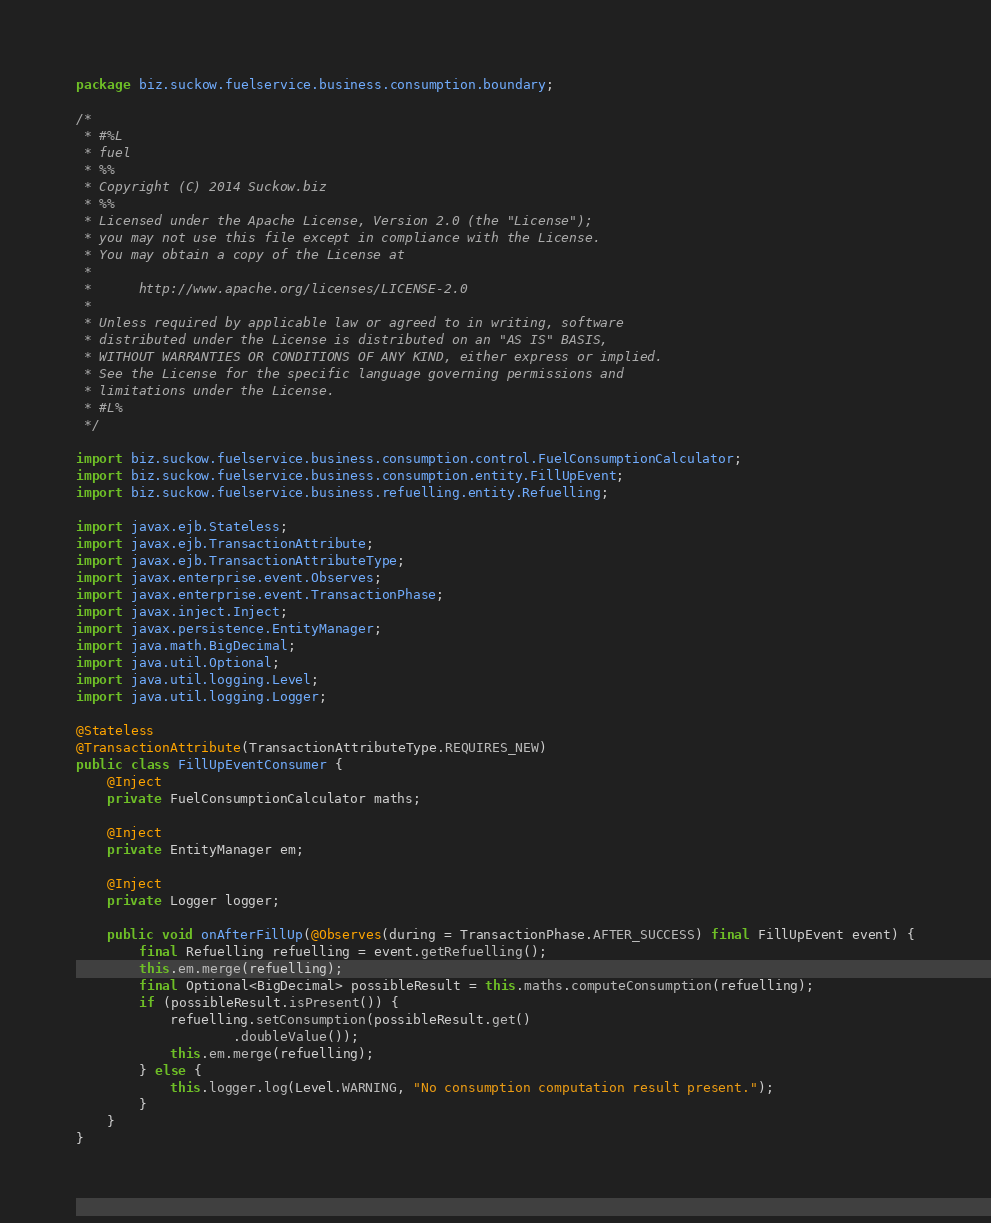<code> <loc_0><loc_0><loc_500><loc_500><_Java_>package biz.suckow.fuelservice.business.consumption.boundary;

/*
 * #%L
 * fuel
 * %%
 * Copyright (C) 2014 Suckow.biz
 * %%
 * Licensed under the Apache License, Version 2.0 (the "License");
 * you may not use this file except in compliance with the License.
 * You may obtain a copy of the License at
 * 
 *      http://www.apache.org/licenses/LICENSE-2.0
 * 
 * Unless required by applicable law or agreed to in writing, software
 * distributed under the License is distributed on an "AS IS" BASIS,
 * WITHOUT WARRANTIES OR CONDITIONS OF ANY KIND, either express or implied.
 * See the License for the specific language governing permissions and
 * limitations under the License.
 * #L%
 */

import biz.suckow.fuelservice.business.consumption.control.FuelConsumptionCalculator;
import biz.suckow.fuelservice.business.consumption.entity.FillUpEvent;
import biz.suckow.fuelservice.business.refuelling.entity.Refuelling;

import javax.ejb.Stateless;
import javax.ejb.TransactionAttribute;
import javax.ejb.TransactionAttributeType;
import javax.enterprise.event.Observes;
import javax.enterprise.event.TransactionPhase;
import javax.inject.Inject;
import javax.persistence.EntityManager;
import java.math.BigDecimal;
import java.util.Optional;
import java.util.logging.Level;
import java.util.logging.Logger;

@Stateless
@TransactionAttribute(TransactionAttributeType.REQUIRES_NEW)
public class FillUpEventConsumer {
    @Inject
    private FuelConsumptionCalculator maths;

    @Inject
    private EntityManager em;

    @Inject
    private Logger logger;

    public void onAfterFillUp(@Observes(during = TransactionPhase.AFTER_SUCCESS) final FillUpEvent event) {
        final Refuelling refuelling = event.getRefuelling();
        this.em.merge(refuelling);
        final Optional<BigDecimal> possibleResult = this.maths.computeConsumption(refuelling);
        if (possibleResult.isPresent()) {
            refuelling.setConsumption(possibleResult.get()
                    .doubleValue());
            this.em.merge(refuelling);
        } else {
            this.logger.log(Level.WARNING, "No consumption computation result present.");
        }
    }
}
</code> 